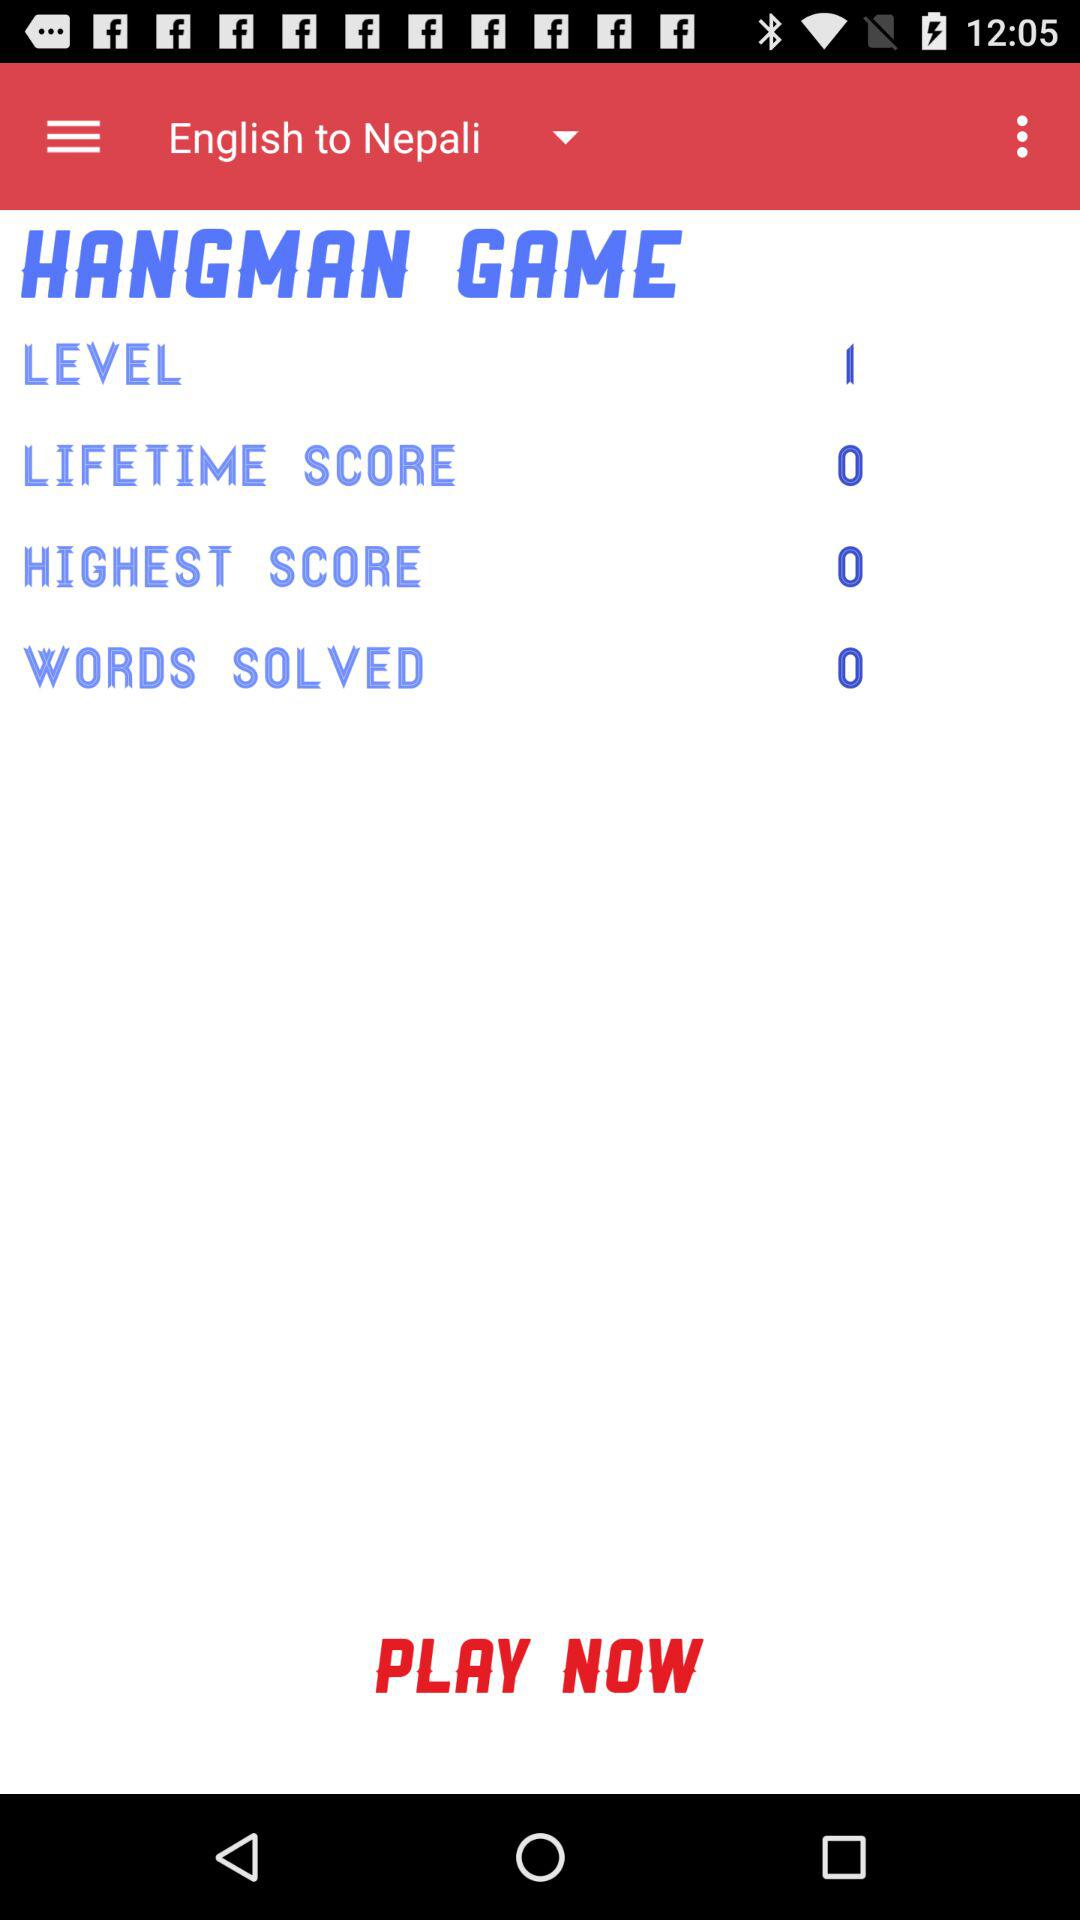What is the count of the solved words? The count is 0. 